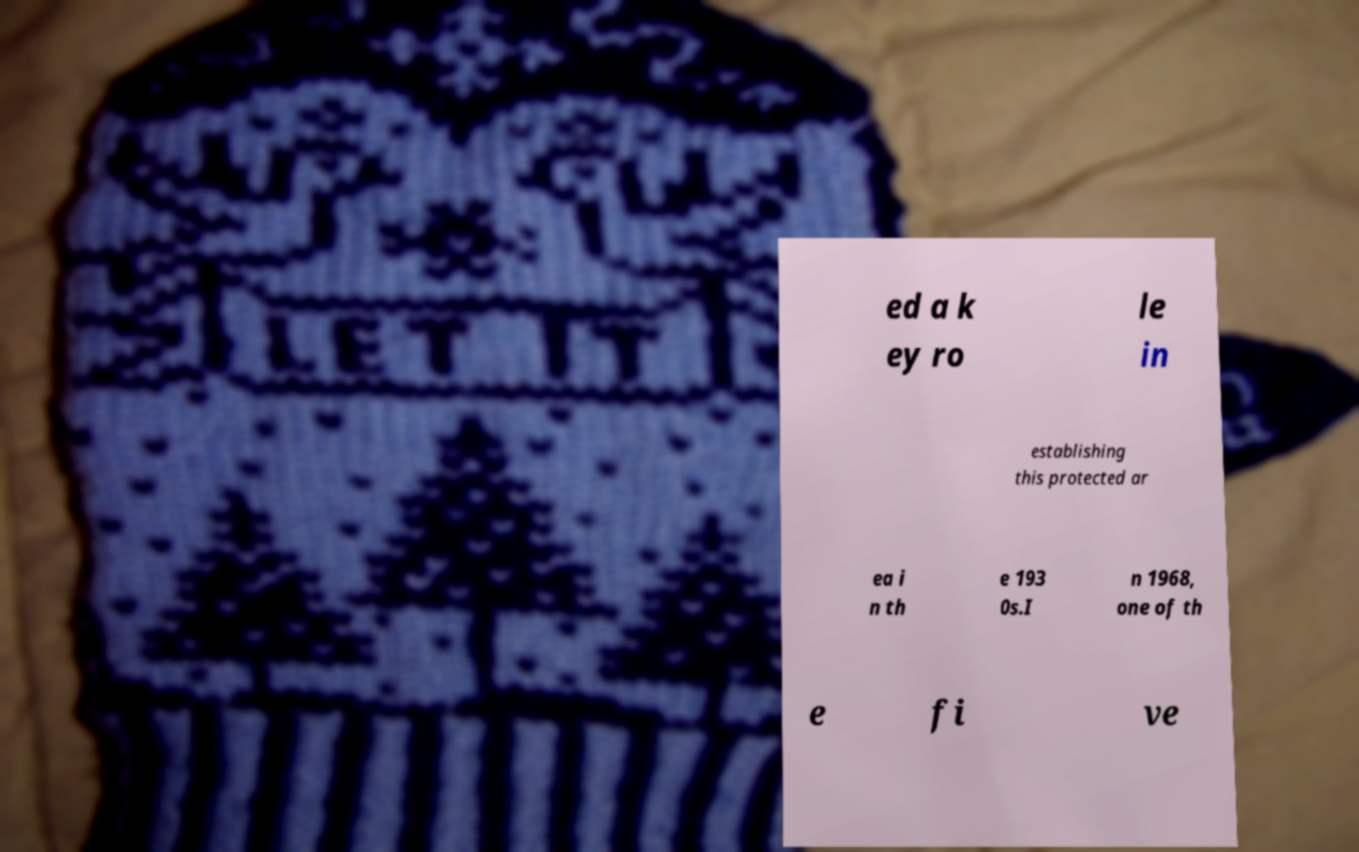Please read and relay the text visible in this image. What does it say? ed a k ey ro le in establishing this protected ar ea i n th e 193 0s.I n 1968, one of th e fi ve 